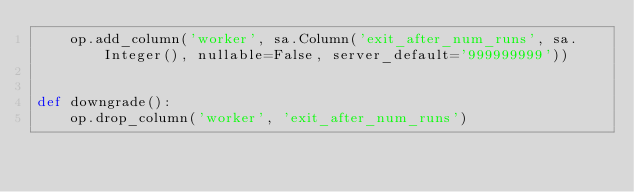<code> <loc_0><loc_0><loc_500><loc_500><_Python_>    op.add_column('worker', sa.Column('exit_after_num_runs', sa.Integer(), nullable=False, server_default='999999999'))


def downgrade():
    op.drop_column('worker', 'exit_after_num_runs')
</code> 